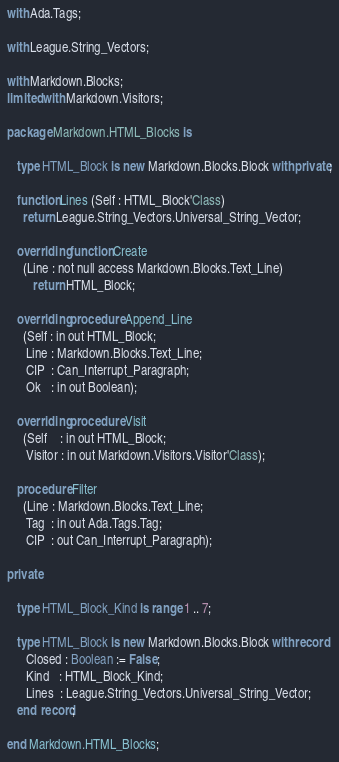<code> <loc_0><loc_0><loc_500><loc_500><_Ada_>with Ada.Tags;

with League.String_Vectors;

with Markdown.Blocks;
limited with Markdown.Visitors;

package Markdown.HTML_Blocks is

   type HTML_Block is new Markdown.Blocks.Block with private;

   function Lines (Self : HTML_Block'Class)
     return League.String_Vectors.Universal_String_Vector;

   overriding function Create
     (Line : not null access Markdown.Blocks.Text_Line)
        return HTML_Block;

   overriding procedure Append_Line
     (Self : in out HTML_Block;
      Line : Markdown.Blocks.Text_Line;
      CIP  : Can_Interrupt_Paragraph;
      Ok   : in out Boolean);

   overriding procedure Visit
     (Self    : in out HTML_Block;
      Visitor : in out Markdown.Visitors.Visitor'Class);

   procedure Filter
     (Line : Markdown.Blocks.Text_Line;
      Tag  : in out Ada.Tags.Tag;
      CIP  : out Can_Interrupt_Paragraph);

private

   type HTML_Block_Kind is range 1 .. 7;

   type HTML_Block is new Markdown.Blocks.Block with record
      Closed : Boolean := False;
      Kind   : HTML_Block_Kind;
      Lines  : League.String_Vectors.Universal_String_Vector;
   end record;

end Markdown.HTML_Blocks;
</code> 